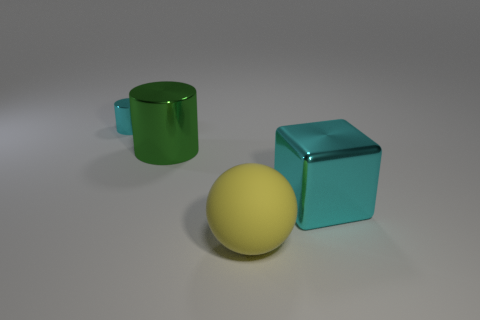Add 1 gray blocks. How many objects exist? 5 Subtract all spheres. How many objects are left? 3 Add 3 red rubber blocks. How many red rubber blocks exist? 3 Subtract 0 blue balls. How many objects are left? 4 Subtract all small shiny cylinders. Subtract all large rubber objects. How many objects are left? 2 Add 3 small cyan metallic things. How many small cyan metallic things are left? 4 